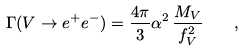Convert formula to latex. <formula><loc_0><loc_0><loc_500><loc_500>\Gamma ( V \rightarrow e ^ { + } e ^ { - } ) = \frac { 4 \pi } { 3 } \alpha ^ { 2 } \, \frac { M _ { V } } { f _ { V } ^ { 2 } } \quad ,</formula> 